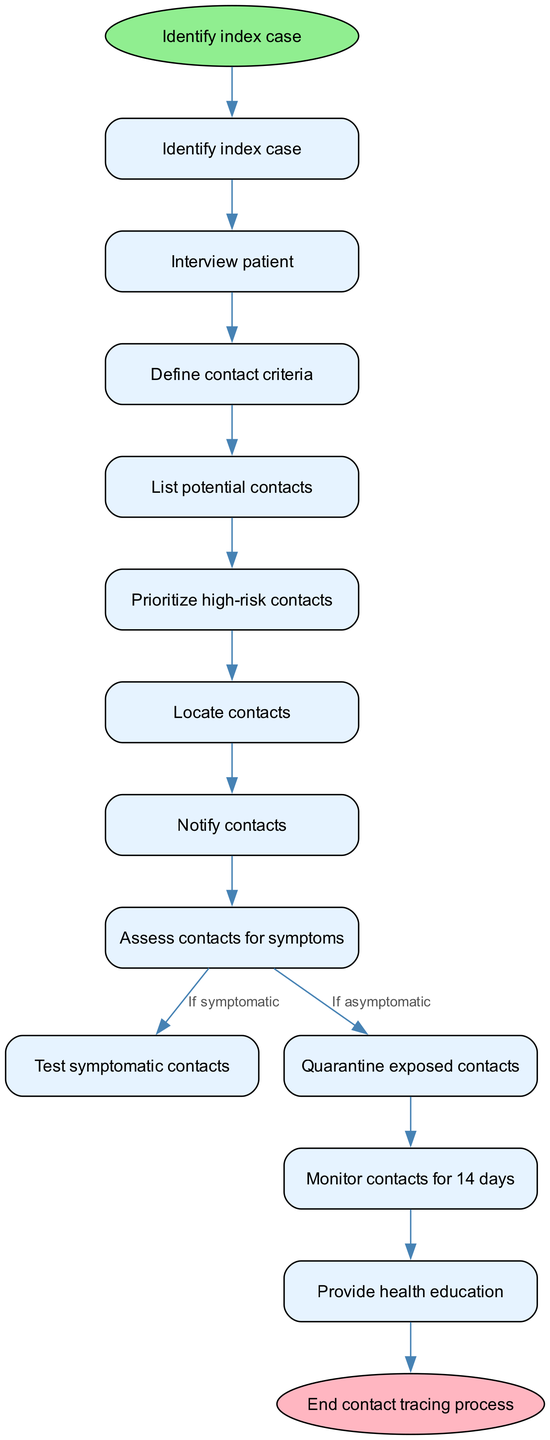What is the first step in the contact tracing procedure? The diagram shows that the first step in the flow is to identify the index case, which is labeled as the start node.
Answer: Identify index case How many nodes are present in the contact tracing procedure? By counting the listed nodes in the diagram and including both the start and end nodes, there are a total of 12 nodes.
Answer: 12 What action follows the notification of contacts? According to the flow, the immediate next action after notifying contacts is to assess contacts for symptoms.
Answer: Assess contacts for symptoms What are the two possible actions after assessing contacts for symptoms? The diagram indicates that after assessing for symptoms, there are two possible actions based on the condition of the contacts: testing for symptomatic contacts or quarantining exposed contacts if asymptomatic.
Answer: Test symptomatic contacts and Quarantine exposed contacts Which node indicates health education is provided? The diagram shows that health education is provided as the last step, which is connected from the monitoring of contacts for 14 days.
Answer: Provide health education If a contact is asymptomatic, what is the next step according to the diagram? When a contact is determined to be asymptomatic after assessment, the next step is to quarantine the exposed contacts as indicated by that path in the flow chart.
Answer: Quarantine exposed contacts Which nodes indicate a flow of action from one to the next without any conditions? The edges connect several nodes directly without conditional branches: starting from identifying the index case to interviewing the patient, defining contact criteria, listing potential contacts, and prioritizing high-risk contacts.
Answer: Identify index case to Interview patient; Interview patient to Define contact criteria; Define contact criteria to List potential contacts; List potential contacts to Prioritize high-risk contacts How many edges connect the nodes in the contact tracing process? By analyzing the connections, there are 11 edges shown in the diagram that link the various nodes.
Answer: 11 